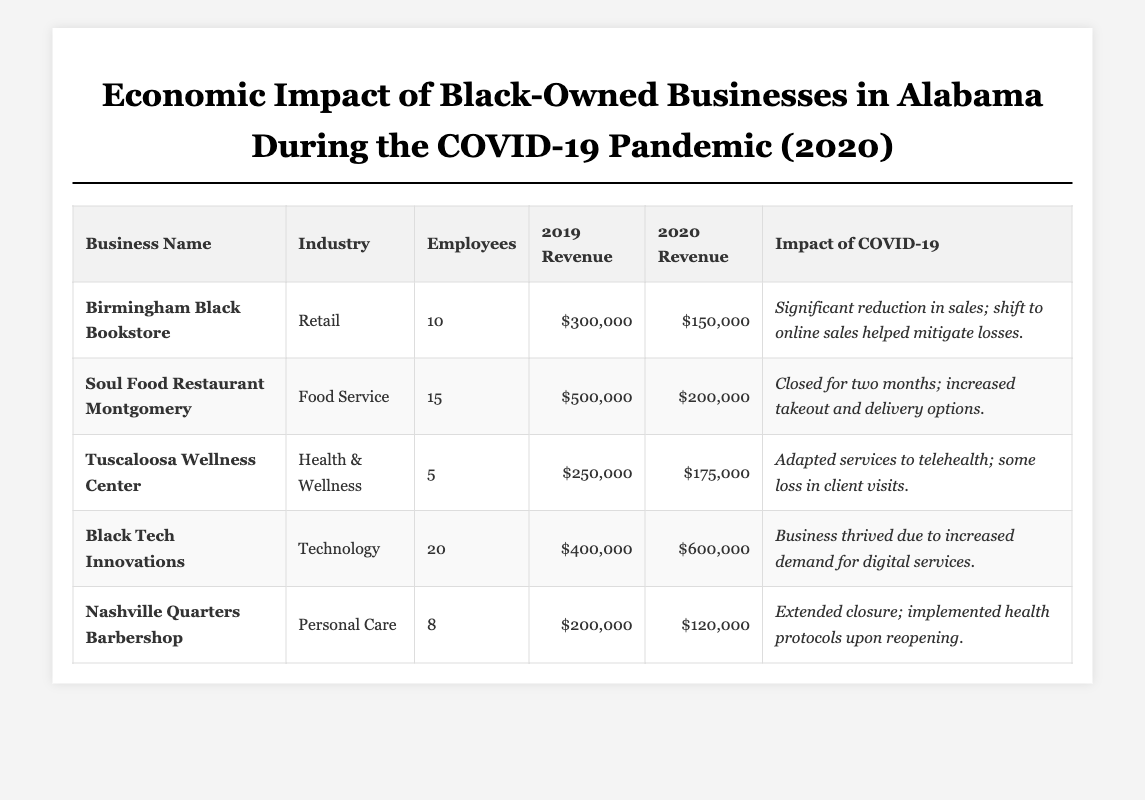What was the annual revenue of Birmingham Black Bookstore in 2020? The table shows that the annual revenue for Birmingham Black Bookstore in 2020 is $150,000.
Answer: $150,000 How many employees did the Soul Food Restaurant Montgomery have? According to the table, Soul Food Restaurant Montgomery had 15 employees listed.
Answer: 15 What is the percentage decrease in annual revenue for Tuscaloosa Wellness Center from 2019 to 2020? The 2019 revenue was $250,000 and the 2020 revenue was $175,000. The decrease is $250,000 - $175,000 = $75,000. The percentage decrease is ($75,000 / $250,000) * 100 = 30%.
Answer: 30% Which business experienced an increase in annual revenue in 2020 compared to 2019? The table indicates that Black Tech Innovations had a revenue increase from $400,000 in 2019 to $600,000 in 2020, confirming the growth.
Answer: Black Tech Innovations Did any of the businesses remain closed for an extended period during the pandemic? Yes, the Soul Food Restaurant Montgomery closed for two months, as stated in the impact of COVID-19.
Answer: Yes What was the total annual revenue of all businesses in 2019? Summing the 2019 revenues: $300,000 (Birmingham Black Bookstore) + $500,000 (Soul Food Restaurant Montgomery) + $250,000 (Tuscaloosa Wellness Center) + $400,000 (Black Tech Innovations) + $200,000 (Nashville Quarters Barbershop) gives $1,650,000 total.
Answer: $1,650,000 Which industry had the highest number of employees based on the data provided? Black Tech Innovations had the most employees listed, with a total of 20, more than any other business in the table.
Answer: Technology What was the combined revenue for the Retail and Food Service businesses in 2020? Adding the 2020 revenues: $150,000 (Birmingham Black Bookstore) + $200,000 (Soul Food Restaurant Montgomery) equals $350,000 combined for these industries.
Answer: $350,000 Was there a business that reported adapting services to telehealth? Yes, the Tuscaloosa Wellness Center adapted its services to telehealth as mentioned in the impact of COVID-19.
Answer: Yes How many businesses had a revenue of less than $200,000 in 2020? The Birmingham Black Bookstore ($150,000), Soul Food Restaurant Montgomery ($200,000), and Nashville Quarters Barbershop ($120,000) all showed revenues below $200,000 when comparing the 2020 figures. Two businesses reported less than this threshold.
Answer: 2 What was the difference in revenue between the business that thrived and the one that experienced the most significant reduction in sales due to COVID-19? Black Tech Innovations had an annual revenue of $600,000, and Birmingham Black Bookstore faced a reduction to $150,000, making the difference $600,000 - $150,000 = $450,000.
Answer: $450,000 